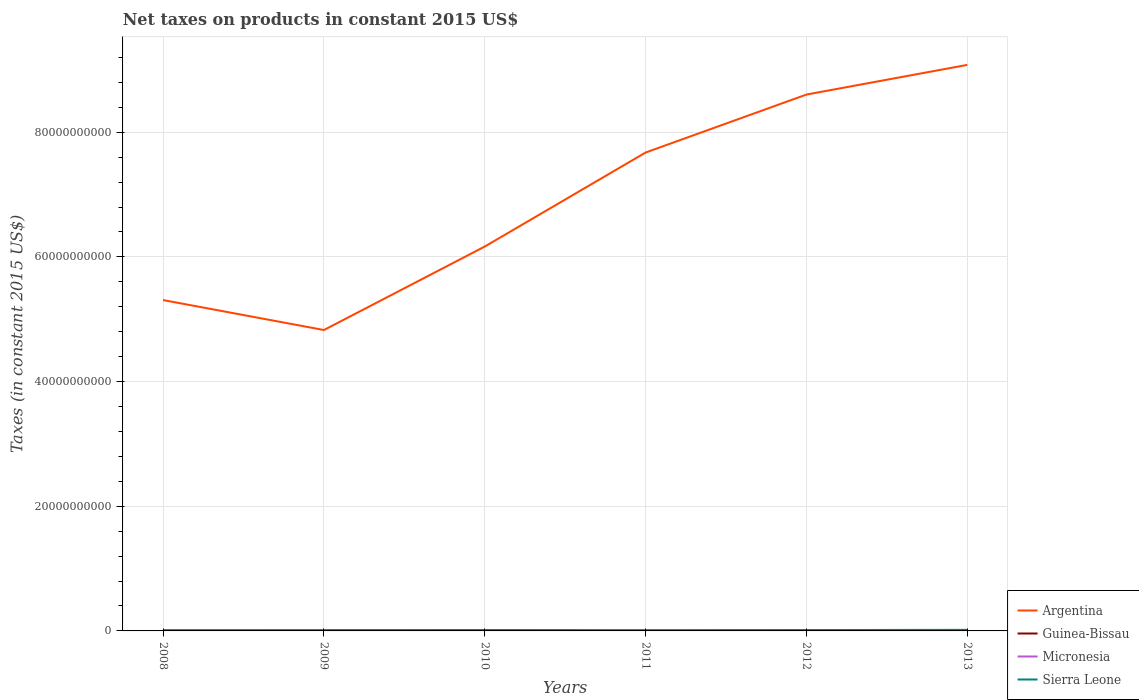Does the line corresponding to Argentina intersect with the line corresponding to Sierra Leone?
Your answer should be compact. No. Across all years, what is the maximum net taxes on products in Micronesia?
Your response must be concise. 1.88e+07. What is the total net taxes on products in Argentina in the graph?
Your response must be concise. -2.91e+1. What is the difference between the highest and the second highest net taxes on products in Micronesia?
Offer a terse response. 7.48e+06. Is the net taxes on products in Sierra Leone strictly greater than the net taxes on products in Micronesia over the years?
Keep it short and to the point. No. How many lines are there?
Keep it short and to the point. 4. What is the difference between two consecutive major ticks on the Y-axis?
Your response must be concise. 2.00e+1. Does the graph contain grids?
Your answer should be very brief. Yes. How are the legend labels stacked?
Offer a very short reply. Vertical. What is the title of the graph?
Offer a very short reply. Net taxes on products in constant 2015 US$. Does "Zambia" appear as one of the legend labels in the graph?
Your response must be concise. No. What is the label or title of the X-axis?
Give a very brief answer. Years. What is the label or title of the Y-axis?
Ensure brevity in your answer.  Taxes (in constant 2015 US$). What is the Taxes (in constant 2015 US$) in Argentina in 2008?
Ensure brevity in your answer.  5.31e+1. What is the Taxes (in constant 2015 US$) in Guinea-Bissau in 2008?
Provide a short and direct response. 2.15e+07. What is the Taxes (in constant 2015 US$) in Micronesia in 2008?
Make the answer very short. 1.88e+07. What is the Taxes (in constant 2015 US$) of Sierra Leone in 2008?
Provide a succinct answer. 1.20e+08. What is the Taxes (in constant 2015 US$) in Argentina in 2009?
Provide a succinct answer. 4.83e+1. What is the Taxes (in constant 2015 US$) of Guinea-Bissau in 2009?
Your answer should be compact. 2.91e+07. What is the Taxes (in constant 2015 US$) in Micronesia in 2009?
Your answer should be compact. 2.20e+07. What is the Taxes (in constant 2015 US$) of Sierra Leone in 2009?
Provide a short and direct response. 1.24e+08. What is the Taxes (in constant 2015 US$) of Argentina in 2010?
Your response must be concise. 6.17e+1. What is the Taxes (in constant 2015 US$) in Guinea-Bissau in 2010?
Offer a very short reply. 3.48e+07. What is the Taxes (in constant 2015 US$) in Micronesia in 2010?
Make the answer very short. 2.54e+07. What is the Taxes (in constant 2015 US$) of Sierra Leone in 2010?
Provide a short and direct response. 1.42e+08. What is the Taxes (in constant 2015 US$) in Argentina in 2011?
Your response must be concise. 7.67e+1. What is the Taxes (in constant 2015 US$) in Guinea-Bissau in 2011?
Offer a terse response. 4.56e+07. What is the Taxes (in constant 2015 US$) in Micronesia in 2011?
Offer a very short reply. 2.60e+07. What is the Taxes (in constant 2015 US$) of Sierra Leone in 2011?
Ensure brevity in your answer.  1.10e+08. What is the Taxes (in constant 2015 US$) of Argentina in 2012?
Make the answer very short. 8.60e+1. What is the Taxes (in constant 2015 US$) of Guinea-Bissau in 2012?
Keep it short and to the point. 3.63e+07. What is the Taxes (in constant 2015 US$) of Micronesia in 2012?
Make the answer very short. 2.63e+07. What is the Taxes (in constant 2015 US$) in Sierra Leone in 2012?
Offer a terse response. 1.40e+08. What is the Taxes (in constant 2015 US$) in Argentina in 2013?
Give a very brief answer. 9.08e+1. What is the Taxes (in constant 2015 US$) in Guinea-Bissau in 2013?
Your response must be concise. 5.57e+07. What is the Taxes (in constant 2015 US$) of Micronesia in 2013?
Ensure brevity in your answer.  2.59e+07. What is the Taxes (in constant 2015 US$) in Sierra Leone in 2013?
Your answer should be compact. 1.72e+08. Across all years, what is the maximum Taxes (in constant 2015 US$) of Argentina?
Offer a terse response. 9.08e+1. Across all years, what is the maximum Taxes (in constant 2015 US$) in Guinea-Bissau?
Give a very brief answer. 5.57e+07. Across all years, what is the maximum Taxes (in constant 2015 US$) of Micronesia?
Keep it short and to the point. 2.63e+07. Across all years, what is the maximum Taxes (in constant 2015 US$) of Sierra Leone?
Keep it short and to the point. 1.72e+08. Across all years, what is the minimum Taxes (in constant 2015 US$) of Argentina?
Your answer should be very brief. 4.83e+1. Across all years, what is the minimum Taxes (in constant 2015 US$) of Guinea-Bissau?
Provide a short and direct response. 2.15e+07. Across all years, what is the minimum Taxes (in constant 2015 US$) in Micronesia?
Keep it short and to the point. 1.88e+07. Across all years, what is the minimum Taxes (in constant 2015 US$) in Sierra Leone?
Offer a terse response. 1.10e+08. What is the total Taxes (in constant 2015 US$) in Argentina in the graph?
Offer a very short reply. 4.17e+11. What is the total Taxes (in constant 2015 US$) of Guinea-Bissau in the graph?
Give a very brief answer. 2.23e+08. What is the total Taxes (in constant 2015 US$) of Micronesia in the graph?
Ensure brevity in your answer.  1.44e+08. What is the total Taxes (in constant 2015 US$) of Sierra Leone in the graph?
Your answer should be very brief. 8.08e+08. What is the difference between the Taxes (in constant 2015 US$) in Argentina in 2008 and that in 2009?
Provide a short and direct response. 4.81e+09. What is the difference between the Taxes (in constant 2015 US$) of Guinea-Bissau in 2008 and that in 2009?
Provide a succinct answer. -7.58e+06. What is the difference between the Taxes (in constant 2015 US$) of Micronesia in 2008 and that in 2009?
Provide a short and direct response. -3.19e+06. What is the difference between the Taxes (in constant 2015 US$) of Sierra Leone in 2008 and that in 2009?
Offer a very short reply. -4.34e+06. What is the difference between the Taxes (in constant 2015 US$) in Argentina in 2008 and that in 2010?
Provide a short and direct response. -8.59e+09. What is the difference between the Taxes (in constant 2015 US$) of Guinea-Bissau in 2008 and that in 2010?
Your response must be concise. -1.33e+07. What is the difference between the Taxes (in constant 2015 US$) in Micronesia in 2008 and that in 2010?
Offer a terse response. -6.60e+06. What is the difference between the Taxes (in constant 2015 US$) of Sierra Leone in 2008 and that in 2010?
Your answer should be compact. -2.21e+07. What is the difference between the Taxes (in constant 2015 US$) of Argentina in 2008 and that in 2011?
Ensure brevity in your answer.  -2.37e+1. What is the difference between the Taxes (in constant 2015 US$) in Guinea-Bissau in 2008 and that in 2011?
Provide a short and direct response. -2.41e+07. What is the difference between the Taxes (in constant 2015 US$) of Micronesia in 2008 and that in 2011?
Offer a very short reply. -7.19e+06. What is the difference between the Taxes (in constant 2015 US$) in Sierra Leone in 2008 and that in 2011?
Give a very brief answer. 9.74e+06. What is the difference between the Taxes (in constant 2015 US$) in Argentina in 2008 and that in 2012?
Keep it short and to the point. -3.30e+1. What is the difference between the Taxes (in constant 2015 US$) in Guinea-Bissau in 2008 and that in 2012?
Your answer should be compact. -1.48e+07. What is the difference between the Taxes (in constant 2015 US$) of Micronesia in 2008 and that in 2012?
Offer a very short reply. -7.48e+06. What is the difference between the Taxes (in constant 2015 US$) of Sierra Leone in 2008 and that in 2012?
Ensure brevity in your answer.  -2.00e+07. What is the difference between the Taxes (in constant 2015 US$) of Argentina in 2008 and that in 2013?
Provide a short and direct response. -3.77e+1. What is the difference between the Taxes (in constant 2015 US$) of Guinea-Bissau in 2008 and that in 2013?
Keep it short and to the point. -3.42e+07. What is the difference between the Taxes (in constant 2015 US$) in Micronesia in 2008 and that in 2013?
Your answer should be compact. -7.08e+06. What is the difference between the Taxes (in constant 2015 US$) of Sierra Leone in 2008 and that in 2013?
Offer a very short reply. -5.19e+07. What is the difference between the Taxes (in constant 2015 US$) in Argentina in 2009 and that in 2010?
Offer a terse response. -1.34e+1. What is the difference between the Taxes (in constant 2015 US$) of Guinea-Bissau in 2009 and that in 2010?
Provide a short and direct response. -5.73e+06. What is the difference between the Taxes (in constant 2015 US$) of Micronesia in 2009 and that in 2010?
Your answer should be very brief. -3.41e+06. What is the difference between the Taxes (in constant 2015 US$) of Sierra Leone in 2009 and that in 2010?
Make the answer very short. -1.78e+07. What is the difference between the Taxes (in constant 2015 US$) in Argentina in 2009 and that in 2011?
Ensure brevity in your answer.  -2.85e+1. What is the difference between the Taxes (in constant 2015 US$) in Guinea-Bissau in 2009 and that in 2011?
Make the answer very short. -1.66e+07. What is the difference between the Taxes (in constant 2015 US$) in Micronesia in 2009 and that in 2011?
Keep it short and to the point. -4.00e+06. What is the difference between the Taxes (in constant 2015 US$) in Sierra Leone in 2009 and that in 2011?
Make the answer very short. 1.41e+07. What is the difference between the Taxes (in constant 2015 US$) of Argentina in 2009 and that in 2012?
Give a very brief answer. -3.78e+1. What is the difference between the Taxes (in constant 2015 US$) of Guinea-Bissau in 2009 and that in 2012?
Offer a very short reply. -7.25e+06. What is the difference between the Taxes (in constant 2015 US$) in Micronesia in 2009 and that in 2012?
Ensure brevity in your answer.  -4.28e+06. What is the difference between the Taxes (in constant 2015 US$) in Sierra Leone in 2009 and that in 2012?
Make the answer very short. -1.56e+07. What is the difference between the Taxes (in constant 2015 US$) in Argentina in 2009 and that in 2013?
Provide a short and direct response. -4.25e+1. What is the difference between the Taxes (in constant 2015 US$) in Guinea-Bissau in 2009 and that in 2013?
Offer a terse response. -2.66e+07. What is the difference between the Taxes (in constant 2015 US$) in Micronesia in 2009 and that in 2013?
Offer a terse response. -3.88e+06. What is the difference between the Taxes (in constant 2015 US$) in Sierra Leone in 2009 and that in 2013?
Keep it short and to the point. -4.76e+07. What is the difference between the Taxes (in constant 2015 US$) of Argentina in 2010 and that in 2011?
Keep it short and to the point. -1.51e+1. What is the difference between the Taxes (in constant 2015 US$) in Guinea-Bissau in 2010 and that in 2011?
Make the answer very short. -1.08e+07. What is the difference between the Taxes (in constant 2015 US$) of Micronesia in 2010 and that in 2011?
Your answer should be very brief. -5.89e+05. What is the difference between the Taxes (in constant 2015 US$) in Sierra Leone in 2010 and that in 2011?
Give a very brief answer. 3.18e+07. What is the difference between the Taxes (in constant 2015 US$) in Argentina in 2010 and that in 2012?
Provide a short and direct response. -2.44e+1. What is the difference between the Taxes (in constant 2015 US$) in Guinea-Bissau in 2010 and that in 2012?
Provide a short and direct response. -1.52e+06. What is the difference between the Taxes (in constant 2015 US$) in Micronesia in 2010 and that in 2012?
Your answer should be very brief. -8.73e+05. What is the difference between the Taxes (in constant 2015 US$) of Sierra Leone in 2010 and that in 2012?
Your response must be concise. 2.11e+06. What is the difference between the Taxes (in constant 2015 US$) of Argentina in 2010 and that in 2013?
Provide a succinct answer. -2.91e+1. What is the difference between the Taxes (in constant 2015 US$) of Guinea-Bissau in 2010 and that in 2013?
Offer a very short reply. -2.09e+07. What is the difference between the Taxes (in constant 2015 US$) in Micronesia in 2010 and that in 2013?
Provide a succinct answer. -4.73e+05. What is the difference between the Taxes (in constant 2015 US$) in Sierra Leone in 2010 and that in 2013?
Make the answer very short. -2.98e+07. What is the difference between the Taxes (in constant 2015 US$) in Argentina in 2011 and that in 2012?
Give a very brief answer. -9.30e+09. What is the difference between the Taxes (in constant 2015 US$) in Guinea-Bissau in 2011 and that in 2012?
Your response must be concise. 9.31e+06. What is the difference between the Taxes (in constant 2015 US$) of Micronesia in 2011 and that in 2012?
Provide a succinct answer. -2.83e+05. What is the difference between the Taxes (in constant 2015 US$) in Sierra Leone in 2011 and that in 2012?
Offer a very short reply. -2.97e+07. What is the difference between the Taxes (in constant 2015 US$) in Argentina in 2011 and that in 2013?
Provide a succinct answer. -1.41e+1. What is the difference between the Taxes (in constant 2015 US$) in Guinea-Bissau in 2011 and that in 2013?
Provide a succinct answer. -1.00e+07. What is the difference between the Taxes (in constant 2015 US$) of Micronesia in 2011 and that in 2013?
Your answer should be compact. 1.17e+05. What is the difference between the Taxes (in constant 2015 US$) in Sierra Leone in 2011 and that in 2013?
Make the answer very short. -6.16e+07. What is the difference between the Taxes (in constant 2015 US$) in Argentina in 2012 and that in 2013?
Your answer should be very brief. -4.76e+09. What is the difference between the Taxes (in constant 2015 US$) of Guinea-Bissau in 2012 and that in 2013?
Your answer should be compact. -1.93e+07. What is the difference between the Taxes (in constant 2015 US$) of Sierra Leone in 2012 and that in 2013?
Offer a terse response. -3.19e+07. What is the difference between the Taxes (in constant 2015 US$) in Argentina in 2008 and the Taxes (in constant 2015 US$) in Guinea-Bissau in 2009?
Give a very brief answer. 5.30e+1. What is the difference between the Taxes (in constant 2015 US$) in Argentina in 2008 and the Taxes (in constant 2015 US$) in Micronesia in 2009?
Offer a very short reply. 5.31e+1. What is the difference between the Taxes (in constant 2015 US$) in Argentina in 2008 and the Taxes (in constant 2015 US$) in Sierra Leone in 2009?
Your answer should be very brief. 5.30e+1. What is the difference between the Taxes (in constant 2015 US$) in Guinea-Bissau in 2008 and the Taxes (in constant 2015 US$) in Micronesia in 2009?
Keep it short and to the point. -5.27e+05. What is the difference between the Taxes (in constant 2015 US$) in Guinea-Bissau in 2008 and the Taxes (in constant 2015 US$) in Sierra Leone in 2009?
Offer a very short reply. -1.03e+08. What is the difference between the Taxes (in constant 2015 US$) of Micronesia in 2008 and the Taxes (in constant 2015 US$) of Sierra Leone in 2009?
Provide a succinct answer. -1.05e+08. What is the difference between the Taxes (in constant 2015 US$) of Argentina in 2008 and the Taxes (in constant 2015 US$) of Guinea-Bissau in 2010?
Ensure brevity in your answer.  5.30e+1. What is the difference between the Taxes (in constant 2015 US$) in Argentina in 2008 and the Taxes (in constant 2015 US$) in Micronesia in 2010?
Your answer should be compact. 5.31e+1. What is the difference between the Taxes (in constant 2015 US$) of Argentina in 2008 and the Taxes (in constant 2015 US$) of Sierra Leone in 2010?
Provide a succinct answer. 5.29e+1. What is the difference between the Taxes (in constant 2015 US$) of Guinea-Bissau in 2008 and the Taxes (in constant 2015 US$) of Micronesia in 2010?
Provide a succinct answer. -3.94e+06. What is the difference between the Taxes (in constant 2015 US$) of Guinea-Bissau in 2008 and the Taxes (in constant 2015 US$) of Sierra Leone in 2010?
Your answer should be compact. -1.20e+08. What is the difference between the Taxes (in constant 2015 US$) of Micronesia in 2008 and the Taxes (in constant 2015 US$) of Sierra Leone in 2010?
Your answer should be very brief. -1.23e+08. What is the difference between the Taxes (in constant 2015 US$) of Argentina in 2008 and the Taxes (in constant 2015 US$) of Guinea-Bissau in 2011?
Provide a succinct answer. 5.30e+1. What is the difference between the Taxes (in constant 2015 US$) in Argentina in 2008 and the Taxes (in constant 2015 US$) in Micronesia in 2011?
Offer a terse response. 5.31e+1. What is the difference between the Taxes (in constant 2015 US$) of Argentina in 2008 and the Taxes (in constant 2015 US$) of Sierra Leone in 2011?
Keep it short and to the point. 5.30e+1. What is the difference between the Taxes (in constant 2015 US$) in Guinea-Bissau in 2008 and the Taxes (in constant 2015 US$) in Micronesia in 2011?
Provide a short and direct response. -4.53e+06. What is the difference between the Taxes (in constant 2015 US$) in Guinea-Bissau in 2008 and the Taxes (in constant 2015 US$) in Sierra Leone in 2011?
Ensure brevity in your answer.  -8.86e+07. What is the difference between the Taxes (in constant 2015 US$) of Micronesia in 2008 and the Taxes (in constant 2015 US$) of Sierra Leone in 2011?
Offer a very short reply. -9.13e+07. What is the difference between the Taxes (in constant 2015 US$) of Argentina in 2008 and the Taxes (in constant 2015 US$) of Guinea-Bissau in 2012?
Provide a short and direct response. 5.30e+1. What is the difference between the Taxes (in constant 2015 US$) in Argentina in 2008 and the Taxes (in constant 2015 US$) in Micronesia in 2012?
Provide a short and direct response. 5.31e+1. What is the difference between the Taxes (in constant 2015 US$) in Argentina in 2008 and the Taxes (in constant 2015 US$) in Sierra Leone in 2012?
Give a very brief answer. 5.29e+1. What is the difference between the Taxes (in constant 2015 US$) of Guinea-Bissau in 2008 and the Taxes (in constant 2015 US$) of Micronesia in 2012?
Offer a terse response. -4.81e+06. What is the difference between the Taxes (in constant 2015 US$) in Guinea-Bissau in 2008 and the Taxes (in constant 2015 US$) in Sierra Leone in 2012?
Provide a succinct answer. -1.18e+08. What is the difference between the Taxes (in constant 2015 US$) in Micronesia in 2008 and the Taxes (in constant 2015 US$) in Sierra Leone in 2012?
Provide a short and direct response. -1.21e+08. What is the difference between the Taxes (in constant 2015 US$) in Argentina in 2008 and the Taxes (in constant 2015 US$) in Guinea-Bissau in 2013?
Your answer should be very brief. 5.30e+1. What is the difference between the Taxes (in constant 2015 US$) in Argentina in 2008 and the Taxes (in constant 2015 US$) in Micronesia in 2013?
Keep it short and to the point. 5.31e+1. What is the difference between the Taxes (in constant 2015 US$) in Argentina in 2008 and the Taxes (in constant 2015 US$) in Sierra Leone in 2013?
Make the answer very short. 5.29e+1. What is the difference between the Taxes (in constant 2015 US$) of Guinea-Bissau in 2008 and the Taxes (in constant 2015 US$) of Micronesia in 2013?
Your answer should be very brief. -4.41e+06. What is the difference between the Taxes (in constant 2015 US$) of Guinea-Bissau in 2008 and the Taxes (in constant 2015 US$) of Sierra Leone in 2013?
Your answer should be compact. -1.50e+08. What is the difference between the Taxes (in constant 2015 US$) of Micronesia in 2008 and the Taxes (in constant 2015 US$) of Sierra Leone in 2013?
Give a very brief answer. -1.53e+08. What is the difference between the Taxes (in constant 2015 US$) in Argentina in 2009 and the Taxes (in constant 2015 US$) in Guinea-Bissau in 2010?
Make the answer very short. 4.82e+1. What is the difference between the Taxes (in constant 2015 US$) in Argentina in 2009 and the Taxes (in constant 2015 US$) in Micronesia in 2010?
Ensure brevity in your answer.  4.82e+1. What is the difference between the Taxes (in constant 2015 US$) of Argentina in 2009 and the Taxes (in constant 2015 US$) of Sierra Leone in 2010?
Ensure brevity in your answer.  4.81e+1. What is the difference between the Taxes (in constant 2015 US$) of Guinea-Bissau in 2009 and the Taxes (in constant 2015 US$) of Micronesia in 2010?
Offer a very short reply. 3.64e+06. What is the difference between the Taxes (in constant 2015 US$) in Guinea-Bissau in 2009 and the Taxes (in constant 2015 US$) in Sierra Leone in 2010?
Your response must be concise. -1.13e+08. What is the difference between the Taxes (in constant 2015 US$) of Micronesia in 2009 and the Taxes (in constant 2015 US$) of Sierra Leone in 2010?
Give a very brief answer. -1.20e+08. What is the difference between the Taxes (in constant 2015 US$) of Argentina in 2009 and the Taxes (in constant 2015 US$) of Guinea-Bissau in 2011?
Make the answer very short. 4.82e+1. What is the difference between the Taxes (in constant 2015 US$) of Argentina in 2009 and the Taxes (in constant 2015 US$) of Micronesia in 2011?
Provide a short and direct response. 4.82e+1. What is the difference between the Taxes (in constant 2015 US$) of Argentina in 2009 and the Taxes (in constant 2015 US$) of Sierra Leone in 2011?
Your answer should be compact. 4.82e+1. What is the difference between the Taxes (in constant 2015 US$) in Guinea-Bissau in 2009 and the Taxes (in constant 2015 US$) in Micronesia in 2011?
Keep it short and to the point. 3.05e+06. What is the difference between the Taxes (in constant 2015 US$) of Guinea-Bissau in 2009 and the Taxes (in constant 2015 US$) of Sierra Leone in 2011?
Offer a terse response. -8.11e+07. What is the difference between the Taxes (in constant 2015 US$) in Micronesia in 2009 and the Taxes (in constant 2015 US$) in Sierra Leone in 2011?
Offer a terse response. -8.81e+07. What is the difference between the Taxes (in constant 2015 US$) in Argentina in 2009 and the Taxes (in constant 2015 US$) in Guinea-Bissau in 2012?
Offer a very short reply. 4.82e+1. What is the difference between the Taxes (in constant 2015 US$) of Argentina in 2009 and the Taxes (in constant 2015 US$) of Micronesia in 2012?
Make the answer very short. 4.82e+1. What is the difference between the Taxes (in constant 2015 US$) of Argentina in 2009 and the Taxes (in constant 2015 US$) of Sierra Leone in 2012?
Provide a short and direct response. 4.81e+1. What is the difference between the Taxes (in constant 2015 US$) of Guinea-Bissau in 2009 and the Taxes (in constant 2015 US$) of Micronesia in 2012?
Give a very brief answer. 2.77e+06. What is the difference between the Taxes (in constant 2015 US$) in Guinea-Bissau in 2009 and the Taxes (in constant 2015 US$) in Sierra Leone in 2012?
Your answer should be very brief. -1.11e+08. What is the difference between the Taxes (in constant 2015 US$) of Micronesia in 2009 and the Taxes (in constant 2015 US$) of Sierra Leone in 2012?
Your answer should be very brief. -1.18e+08. What is the difference between the Taxes (in constant 2015 US$) in Argentina in 2009 and the Taxes (in constant 2015 US$) in Guinea-Bissau in 2013?
Your response must be concise. 4.82e+1. What is the difference between the Taxes (in constant 2015 US$) in Argentina in 2009 and the Taxes (in constant 2015 US$) in Micronesia in 2013?
Offer a very short reply. 4.82e+1. What is the difference between the Taxes (in constant 2015 US$) of Argentina in 2009 and the Taxes (in constant 2015 US$) of Sierra Leone in 2013?
Provide a short and direct response. 4.81e+1. What is the difference between the Taxes (in constant 2015 US$) of Guinea-Bissau in 2009 and the Taxes (in constant 2015 US$) of Micronesia in 2013?
Offer a very short reply. 3.17e+06. What is the difference between the Taxes (in constant 2015 US$) in Guinea-Bissau in 2009 and the Taxes (in constant 2015 US$) in Sierra Leone in 2013?
Provide a succinct answer. -1.43e+08. What is the difference between the Taxes (in constant 2015 US$) of Micronesia in 2009 and the Taxes (in constant 2015 US$) of Sierra Leone in 2013?
Your answer should be very brief. -1.50e+08. What is the difference between the Taxes (in constant 2015 US$) in Argentina in 2010 and the Taxes (in constant 2015 US$) in Guinea-Bissau in 2011?
Provide a short and direct response. 6.16e+1. What is the difference between the Taxes (in constant 2015 US$) of Argentina in 2010 and the Taxes (in constant 2015 US$) of Micronesia in 2011?
Provide a short and direct response. 6.16e+1. What is the difference between the Taxes (in constant 2015 US$) in Argentina in 2010 and the Taxes (in constant 2015 US$) in Sierra Leone in 2011?
Your response must be concise. 6.16e+1. What is the difference between the Taxes (in constant 2015 US$) in Guinea-Bissau in 2010 and the Taxes (in constant 2015 US$) in Micronesia in 2011?
Provide a short and direct response. 8.78e+06. What is the difference between the Taxes (in constant 2015 US$) of Guinea-Bissau in 2010 and the Taxes (in constant 2015 US$) of Sierra Leone in 2011?
Offer a very short reply. -7.53e+07. What is the difference between the Taxes (in constant 2015 US$) in Micronesia in 2010 and the Taxes (in constant 2015 US$) in Sierra Leone in 2011?
Keep it short and to the point. -8.47e+07. What is the difference between the Taxes (in constant 2015 US$) in Argentina in 2010 and the Taxes (in constant 2015 US$) in Guinea-Bissau in 2012?
Your answer should be compact. 6.16e+1. What is the difference between the Taxes (in constant 2015 US$) of Argentina in 2010 and the Taxes (in constant 2015 US$) of Micronesia in 2012?
Your answer should be very brief. 6.16e+1. What is the difference between the Taxes (in constant 2015 US$) in Argentina in 2010 and the Taxes (in constant 2015 US$) in Sierra Leone in 2012?
Offer a very short reply. 6.15e+1. What is the difference between the Taxes (in constant 2015 US$) of Guinea-Bissau in 2010 and the Taxes (in constant 2015 US$) of Micronesia in 2012?
Provide a succinct answer. 8.49e+06. What is the difference between the Taxes (in constant 2015 US$) of Guinea-Bissau in 2010 and the Taxes (in constant 2015 US$) of Sierra Leone in 2012?
Provide a short and direct response. -1.05e+08. What is the difference between the Taxes (in constant 2015 US$) in Micronesia in 2010 and the Taxes (in constant 2015 US$) in Sierra Leone in 2012?
Make the answer very short. -1.14e+08. What is the difference between the Taxes (in constant 2015 US$) in Argentina in 2010 and the Taxes (in constant 2015 US$) in Guinea-Bissau in 2013?
Your response must be concise. 6.16e+1. What is the difference between the Taxes (in constant 2015 US$) of Argentina in 2010 and the Taxes (in constant 2015 US$) of Micronesia in 2013?
Give a very brief answer. 6.16e+1. What is the difference between the Taxes (in constant 2015 US$) in Argentina in 2010 and the Taxes (in constant 2015 US$) in Sierra Leone in 2013?
Your answer should be very brief. 6.15e+1. What is the difference between the Taxes (in constant 2015 US$) in Guinea-Bissau in 2010 and the Taxes (in constant 2015 US$) in Micronesia in 2013?
Your answer should be compact. 8.89e+06. What is the difference between the Taxes (in constant 2015 US$) in Guinea-Bissau in 2010 and the Taxes (in constant 2015 US$) in Sierra Leone in 2013?
Provide a succinct answer. -1.37e+08. What is the difference between the Taxes (in constant 2015 US$) in Micronesia in 2010 and the Taxes (in constant 2015 US$) in Sierra Leone in 2013?
Give a very brief answer. -1.46e+08. What is the difference between the Taxes (in constant 2015 US$) of Argentina in 2011 and the Taxes (in constant 2015 US$) of Guinea-Bissau in 2012?
Ensure brevity in your answer.  7.67e+1. What is the difference between the Taxes (in constant 2015 US$) of Argentina in 2011 and the Taxes (in constant 2015 US$) of Micronesia in 2012?
Offer a very short reply. 7.67e+1. What is the difference between the Taxes (in constant 2015 US$) in Argentina in 2011 and the Taxes (in constant 2015 US$) in Sierra Leone in 2012?
Keep it short and to the point. 7.66e+1. What is the difference between the Taxes (in constant 2015 US$) in Guinea-Bissau in 2011 and the Taxes (in constant 2015 US$) in Micronesia in 2012?
Your answer should be very brief. 1.93e+07. What is the difference between the Taxes (in constant 2015 US$) in Guinea-Bissau in 2011 and the Taxes (in constant 2015 US$) in Sierra Leone in 2012?
Your answer should be very brief. -9.42e+07. What is the difference between the Taxes (in constant 2015 US$) of Micronesia in 2011 and the Taxes (in constant 2015 US$) of Sierra Leone in 2012?
Offer a terse response. -1.14e+08. What is the difference between the Taxes (in constant 2015 US$) in Argentina in 2011 and the Taxes (in constant 2015 US$) in Guinea-Bissau in 2013?
Your answer should be compact. 7.67e+1. What is the difference between the Taxes (in constant 2015 US$) in Argentina in 2011 and the Taxes (in constant 2015 US$) in Micronesia in 2013?
Your answer should be compact. 7.67e+1. What is the difference between the Taxes (in constant 2015 US$) in Argentina in 2011 and the Taxes (in constant 2015 US$) in Sierra Leone in 2013?
Provide a short and direct response. 7.66e+1. What is the difference between the Taxes (in constant 2015 US$) of Guinea-Bissau in 2011 and the Taxes (in constant 2015 US$) of Micronesia in 2013?
Your response must be concise. 1.97e+07. What is the difference between the Taxes (in constant 2015 US$) in Guinea-Bissau in 2011 and the Taxes (in constant 2015 US$) in Sierra Leone in 2013?
Your answer should be very brief. -1.26e+08. What is the difference between the Taxes (in constant 2015 US$) in Micronesia in 2011 and the Taxes (in constant 2015 US$) in Sierra Leone in 2013?
Provide a short and direct response. -1.46e+08. What is the difference between the Taxes (in constant 2015 US$) in Argentina in 2012 and the Taxes (in constant 2015 US$) in Guinea-Bissau in 2013?
Offer a terse response. 8.60e+1. What is the difference between the Taxes (in constant 2015 US$) in Argentina in 2012 and the Taxes (in constant 2015 US$) in Micronesia in 2013?
Ensure brevity in your answer.  8.60e+1. What is the difference between the Taxes (in constant 2015 US$) of Argentina in 2012 and the Taxes (in constant 2015 US$) of Sierra Leone in 2013?
Your answer should be very brief. 8.59e+1. What is the difference between the Taxes (in constant 2015 US$) in Guinea-Bissau in 2012 and the Taxes (in constant 2015 US$) in Micronesia in 2013?
Provide a succinct answer. 1.04e+07. What is the difference between the Taxes (in constant 2015 US$) in Guinea-Bissau in 2012 and the Taxes (in constant 2015 US$) in Sierra Leone in 2013?
Make the answer very short. -1.35e+08. What is the difference between the Taxes (in constant 2015 US$) of Micronesia in 2012 and the Taxes (in constant 2015 US$) of Sierra Leone in 2013?
Your answer should be very brief. -1.45e+08. What is the average Taxes (in constant 2015 US$) of Argentina per year?
Keep it short and to the point. 6.94e+1. What is the average Taxes (in constant 2015 US$) in Guinea-Bissau per year?
Make the answer very short. 3.72e+07. What is the average Taxes (in constant 2015 US$) in Micronesia per year?
Offer a very short reply. 2.41e+07. What is the average Taxes (in constant 2015 US$) of Sierra Leone per year?
Give a very brief answer. 1.35e+08. In the year 2008, what is the difference between the Taxes (in constant 2015 US$) in Argentina and Taxes (in constant 2015 US$) in Guinea-Bissau?
Your answer should be very brief. 5.31e+1. In the year 2008, what is the difference between the Taxes (in constant 2015 US$) of Argentina and Taxes (in constant 2015 US$) of Micronesia?
Provide a succinct answer. 5.31e+1. In the year 2008, what is the difference between the Taxes (in constant 2015 US$) in Argentina and Taxes (in constant 2015 US$) in Sierra Leone?
Your answer should be very brief. 5.30e+1. In the year 2008, what is the difference between the Taxes (in constant 2015 US$) in Guinea-Bissau and Taxes (in constant 2015 US$) in Micronesia?
Your answer should be very brief. 2.67e+06. In the year 2008, what is the difference between the Taxes (in constant 2015 US$) of Guinea-Bissau and Taxes (in constant 2015 US$) of Sierra Leone?
Your answer should be very brief. -9.84e+07. In the year 2008, what is the difference between the Taxes (in constant 2015 US$) of Micronesia and Taxes (in constant 2015 US$) of Sierra Leone?
Keep it short and to the point. -1.01e+08. In the year 2009, what is the difference between the Taxes (in constant 2015 US$) of Argentina and Taxes (in constant 2015 US$) of Guinea-Bissau?
Give a very brief answer. 4.82e+1. In the year 2009, what is the difference between the Taxes (in constant 2015 US$) in Argentina and Taxes (in constant 2015 US$) in Micronesia?
Make the answer very short. 4.83e+1. In the year 2009, what is the difference between the Taxes (in constant 2015 US$) in Argentina and Taxes (in constant 2015 US$) in Sierra Leone?
Make the answer very short. 4.81e+1. In the year 2009, what is the difference between the Taxes (in constant 2015 US$) in Guinea-Bissau and Taxes (in constant 2015 US$) in Micronesia?
Ensure brevity in your answer.  7.05e+06. In the year 2009, what is the difference between the Taxes (in constant 2015 US$) in Guinea-Bissau and Taxes (in constant 2015 US$) in Sierra Leone?
Your answer should be compact. -9.51e+07. In the year 2009, what is the difference between the Taxes (in constant 2015 US$) in Micronesia and Taxes (in constant 2015 US$) in Sierra Leone?
Provide a succinct answer. -1.02e+08. In the year 2010, what is the difference between the Taxes (in constant 2015 US$) in Argentina and Taxes (in constant 2015 US$) in Guinea-Bissau?
Make the answer very short. 6.16e+1. In the year 2010, what is the difference between the Taxes (in constant 2015 US$) of Argentina and Taxes (in constant 2015 US$) of Micronesia?
Keep it short and to the point. 6.16e+1. In the year 2010, what is the difference between the Taxes (in constant 2015 US$) in Argentina and Taxes (in constant 2015 US$) in Sierra Leone?
Offer a very short reply. 6.15e+1. In the year 2010, what is the difference between the Taxes (in constant 2015 US$) in Guinea-Bissau and Taxes (in constant 2015 US$) in Micronesia?
Offer a very short reply. 9.37e+06. In the year 2010, what is the difference between the Taxes (in constant 2015 US$) of Guinea-Bissau and Taxes (in constant 2015 US$) of Sierra Leone?
Your answer should be very brief. -1.07e+08. In the year 2010, what is the difference between the Taxes (in constant 2015 US$) in Micronesia and Taxes (in constant 2015 US$) in Sierra Leone?
Offer a very short reply. -1.17e+08. In the year 2011, what is the difference between the Taxes (in constant 2015 US$) of Argentina and Taxes (in constant 2015 US$) of Guinea-Bissau?
Provide a succinct answer. 7.67e+1. In the year 2011, what is the difference between the Taxes (in constant 2015 US$) of Argentina and Taxes (in constant 2015 US$) of Micronesia?
Make the answer very short. 7.67e+1. In the year 2011, what is the difference between the Taxes (in constant 2015 US$) in Argentina and Taxes (in constant 2015 US$) in Sierra Leone?
Offer a terse response. 7.66e+1. In the year 2011, what is the difference between the Taxes (in constant 2015 US$) of Guinea-Bissau and Taxes (in constant 2015 US$) of Micronesia?
Ensure brevity in your answer.  1.96e+07. In the year 2011, what is the difference between the Taxes (in constant 2015 US$) of Guinea-Bissau and Taxes (in constant 2015 US$) of Sierra Leone?
Ensure brevity in your answer.  -6.45e+07. In the year 2011, what is the difference between the Taxes (in constant 2015 US$) in Micronesia and Taxes (in constant 2015 US$) in Sierra Leone?
Make the answer very short. -8.41e+07. In the year 2012, what is the difference between the Taxes (in constant 2015 US$) of Argentina and Taxes (in constant 2015 US$) of Guinea-Bissau?
Ensure brevity in your answer.  8.60e+1. In the year 2012, what is the difference between the Taxes (in constant 2015 US$) in Argentina and Taxes (in constant 2015 US$) in Micronesia?
Provide a short and direct response. 8.60e+1. In the year 2012, what is the difference between the Taxes (in constant 2015 US$) in Argentina and Taxes (in constant 2015 US$) in Sierra Leone?
Offer a very short reply. 8.59e+1. In the year 2012, what is the difference between the Taxes (in constant 2015 US$) in Guinea-Bissau and Taxes (in constant 2015 US$) in Micronesia?
Make the answer very short. 1.00e+07. In the year 2012, what is the difference between the Taxes (in constant 2015 US$) in Guinea-Bissau and Taxes (in constant 2015 US$) in Sierra Leone?
Offer a terse response. -1.04e+08. In the year 2012, what is the difference between the Taxes (in constant 2015 US$) of Micronesia and Taxes (in constant 2015 US$) of Sierra Leone?
Give a very brief answer. -1.14e+08. In the year 2013, what is the difference between the Taxes (in constant 2015 US$) of Argentina and Taxes (in constant 2015 US$) of Guinea-Bissau?
Give a very brief answer. 9.08e+1. In the year 2013, what is the difference between the Taxes (in constant 2015 US$) of Argentina and Taxes (in constant 2015 US$) of Micronesia?
Keep it short and to the point. 9.08e+1. In the year 2013, what is the difference between the Taxes (in constant 2015 US$) in Argentina and Taxes (in constant 2015 US$) in Sierra Leone?
Give a very brief answer. 9.06e+1. In the year 2013, what is the difference between the Taxes (in constant 2015 US$) in Guinea-Bissau and Taxes (in constant 2015 US$) in Micronesia?
Offer a terse response. 2.98e+07. In the year 2013, what is the difference between the Taxes (in constant 2015 US$) in Guinea-Bissau and Taxes (in constant 2015 US$) in Sierra Leone?
Make the answer very short. -1.16e+08. In the year 2013, what is the difference between the Taxes (in constant 2015 US$) of Micronesia and Taxes (in constant 2015 US$) of Sierra Leone?
Keep it short and to the point. -1.46e+08. What is the ratio of the Taxes (in constant 2015 US$) in Argentina in 2008 to that in 2009?
Your answer should be compact. 1.1. What is the ratio of the Taxes (in constant 2015 US$) in Guinea-Bissau in 2008 to that in 2009?
Make the answer very short. 0.74. What is the ratio of the Taxes (in constant 2015 US$) of Micronesia in 2008 to that in 2009?
Offer a terse response. 0.85. What is the ratio of the Taxes (in constant 2015 US$) in Sierra Leone in 2008 to that in 2009?
Your answer should be compact. 0.96. What is the ratio of the Taxes (in constant 2015 US$) of Argentina in 2008 to that in 2010?
Your response must be concise. 0.86. What is the ratio of the Taxes (in constant 2015 US$) of Guinea-Bissau in 2008 to that in 2010?
Provide a succinct answer. 0.62. What is the ratio of the Taxes (in constant 2015 US$) of Micronesia in 2008 to that in 2010?
Your answer should be compact. 0.74. What is the ratio of the Taxes (in constant 2015 US$) of Sierra Leone in 2008 to that in 2010?
Offer a terse response. 0.84. What is the ratio of the Taxes (in constant 2015 US$) of Argentina in 2008 to that in 2011?
Provide a succinct answer. 0.69. What is the ratio of the Taxes (in constant 2015 US$) of Guinea-Bissau in 2008 to that in 2011?
Your answer should be very brief. 0.47. What is the ratio of the Taxes (in constant 2015 US$) of Micronesia in 2008 to that in 2011?
Give a very brief answer. 0.72. What is the ratio of the Taxes (in constant 2015 US$) of Sierra Leone in 2008 to that in 2011?
Ensure brevity in your answer.  1.09. What is the ratio of the Taxes (in constant 2015 US$) of Argentina in 2008 to that in 2012?
Make the answer very short. 0.62. What is the ratio of the Taxes (in constant 2015 US$) of Guinea-Bissau in 2008 to that in 2012?
Provide a short and direct response. 0.59. What is the ratio of the Taxes (in constant 2015 US$) of Micronesia in 2008 to that in 2012?
Provide a succinct answer. 0.72. What is the ratio of the Taxes (in constant 2015 US$) in Argentina in 2008 to that in 2013?
Your answer should be very brief. 0.58. What is the ratio of the Taxes (in constant 2015 US$) of Guinea-Bissau in 2008 to that in 2013?
Give a very brief answer. 0.39. What is the ratio of the Taxes (in constant 2015 US$) in Micronesia in 2008 to that in 2013?
Give a very brief answer. 0.73. What is the ratio of the Taxes (in constant 2015 US$) of Sierra Leone in 2008 to that in 2013?
Your answer should be compact. 0.7. What is the ratio of the Taxes (in constant 2015 US$) of Argentina in 2009 to that in 2010?
Make the answer very short. 0.78. What is the ratio of the Taxes (in constant 2015 US$) of Guinea-Bissau in 2009 to that in 2010?
Give a very brief answer. 0.84. What is the ratio of the Taxes (in constant 2015 US$) in Micronesia in 2009 to that in 2010?
Make the answer very short. 0.87. What is the ratio of the Taxes (in constant 2015 US$) of Sierra Leone in 2009 to that in 2010?
Your response must be concise. 0.87. What is the ratio of the Taxes (in constant 2015 US$) of Argentina in 2009 to that in 2011?
Provide a short and direct response. 0.63. What is the ratio of the Taxes (in constant 2015 US$) in Guinea-Bissau in 2009 to that in 2011?
Give a very brief answer. 0.64. What is the ratio of the Taxes (in constant 2015 US$) of Micronesia in 2009 to that in 2011?
Ensure brevity in your answer.  0.85. What is the ratio of the Taxes (in constant 2015 US$) of Sierra Leone in 2009 to that in 2011?
Give a very brief answer. 1.13. What is the ratio of the Taxes (in constant 2015 US$) in Argentina in 2009 to that in 2012?
Your response must be concise. 0.56. What is the ratio of the Taxes (in constant 2015 US$) of Guinea-Bissau in 2009 to that in 2012?
Your answer should be very brief. 0.8. What is the ratio of the Taxes (in constant 2015 US$) of Micronesia in 2009 to that in 2012?
Provide a short and direct response. 0.84. What is the ratio of the Taxes (in constant 2015 US$) in Sierra Leone in 2009 to that in 2012?
Give a very brief answer. 0.89. What is the ratio of the Taxes (in constant 2015 US$) of Argentina in 2009 to that in 2013?
Offer a terse response. 0.53. What is the ratio of the Taxes (in constant 2015 US$) in Guinea-Bissau in 2009 to that in 2013?
Your answer should be compact. 0.52. What is the ratio of the Taxes (in constant 2015 US$) in Micronesia in 2009 to that in 2013?
Ensure brevity in your answer.  0.85. What is the ratio of the Taxes (in constant 2015 US$) of Sierra Leone in 2009 to that in 2013?
Your answer should be very brief. 0.72. What is the ratio of the Taxes (in constant 2015 US$) of Argentina in 2010 to that in 2011?
Your answer should be compact. 0.8. What is the ratio of the Taxes (in constant 2015 US$) in Guinea-Bissau in 2010 to that in 2011?
Make the answer very short. 0.76. What is the ratio of the Taxes (in constant 2015 US$) in Micronesia in 2010 to that in 2011?
Your answer should be very brief. 0.98. What is the ratio of the Taxes (in constant 2015 US$) in Sierra Leone in 2010 to that in 2011?
Ensure brevity in your answer.  1.29. What is the ratio of the Taxes (in constant 2015 US$) in Argentina in 2010 to that in 2012?
Give a very brief answer. 0.72. What is the ratio of the Taxes (in constant 2015 US$) in Guinea-Bissau in 2010 to that in 2012?
Offer a very short reply. 0.96. What is the ratio of the Taxes (in constant 2015 US$) of Micronesia in 2010 to that in 2012?
Give a very brief answer. 0.97. What is the ratio of the Taxes (in constant 2015 US$) in Sierra Leone in 2010 to that in 2012?
Give a very brief answer. 1.02. What is the ratio of the Taxes (in constant 2015 US$) in Argentina in 2010 to that in 2013?
Offer a very short reply. 0.68. What is the ratio of the Taxes (in constant 2015 US$) in Guinea-Bissau in 2010 to that in 2013?
Your answer should be very brief. 0.63. What is the ratio of the Taxes (in constant 2015 US$) of Micronesia in 2010 to that in 2013?
Ensure brevity in your answer.  0.98. What is the ratio of the Taxes (in constant 2015 US$) of Sierra Leone in 2010 to that in 2013?
Offer a terse response. 0.83. What is the ratio of the Taxes (in constant 2015 US$) in Argentina in 2011 to that in 2012?
Provide a short and direct response. 0.89. What is the ratio of the Taxes (in constant 2015 US$) of Guinea-Bissau in 2011 to that in 2012?
Make the answer very short. 1.26. What is the ratio of the Taxes (in constant 2015 US$) of Micronesia in 2011 to that in 2012?
Ensure brevity in your answer.  0.99. What is the ratio of the Taxes (in constant 2015 US$) of Sierra Leone in 2011 to that in 2012?
Provide a succinct answer. 0.79. What is the ratio of the Taxes (in constant 2015 US$) of Argentina in 2011 to that in 2013?
Offer a terse response. 0.85. What is the ratio of the Taxes (in constant 2015 US$) of Guinea-Bissau in 2011 to that in 2013?
Offer a terse response. 0.82. What is the ratio of the Taxes (in constant 2015 US$) of Micronesia in 2011 to that in 2013?
Give a very brief answer. 1. What is the ratio of the Taxes (in constant 2015 US$) of Sierra Leone in 2011 to that in 2013?
Provide a short and direct response. 0.64. What is the ratio of the Taxes (in constant 2015 US$) of Argentina in 2012 to that in 2013?
Your answer should be very brief. 0.95. What is the ratio of the Taxes (in constant 2015 US$) of Guinea-Bissau in 2012 to that in 2013?
Ensure brevity in your answer.  0.65. What is the ratio of the Taxes (in constant 2015 US$) of Micronesia in 2012 to that in 2013?
Your answer should be very brief. 1.02. What is the ratio of the Taxes (in constant 2015 US$) of Sierra Leone in 2012 to that in 2013?
Your answer should be compact. 0.81. What is the difference between the highest and the second highest Taxes (in constant 2015 US$) of Argentina?
Give a very brief answer. 4.76e+09. What is the difference between the highest and the second highest Taxes (in constant 2015 US$) in Guinea-Bissau?
Offer a terse response. 1.00e+07. What is the difference between the highest and the second highest Taxes (in constant 2015 US$) of Micronesia?
Your answer should be very brief. 2.83e+05. What is the difference between the highest and the second highest Taxes (in constant 2015 US$) in Sierra Leone?
Make the answer very short. 2.98e+07. What is the difference between the highest and the lowest Taxes (in constant 2015 US$) of Argentina?
Your answer should be compact. 4.25e+1. What is the difference between the highest and the lowest Taxes (in constant 2015 US$) of Guinea-Bissau?
Provide a succinct answer. 3.42e+07. What is the difference between the highest and the lowest Taxes (in constant 2015 US$) of Micronesia?
Give a very brief answer. 7.48e+06. What is the difference between the highest and the lowest Taxes (in constant 2015 US$) in Sierra Leone?
Provide a succinct answer. 6.16e+07. 